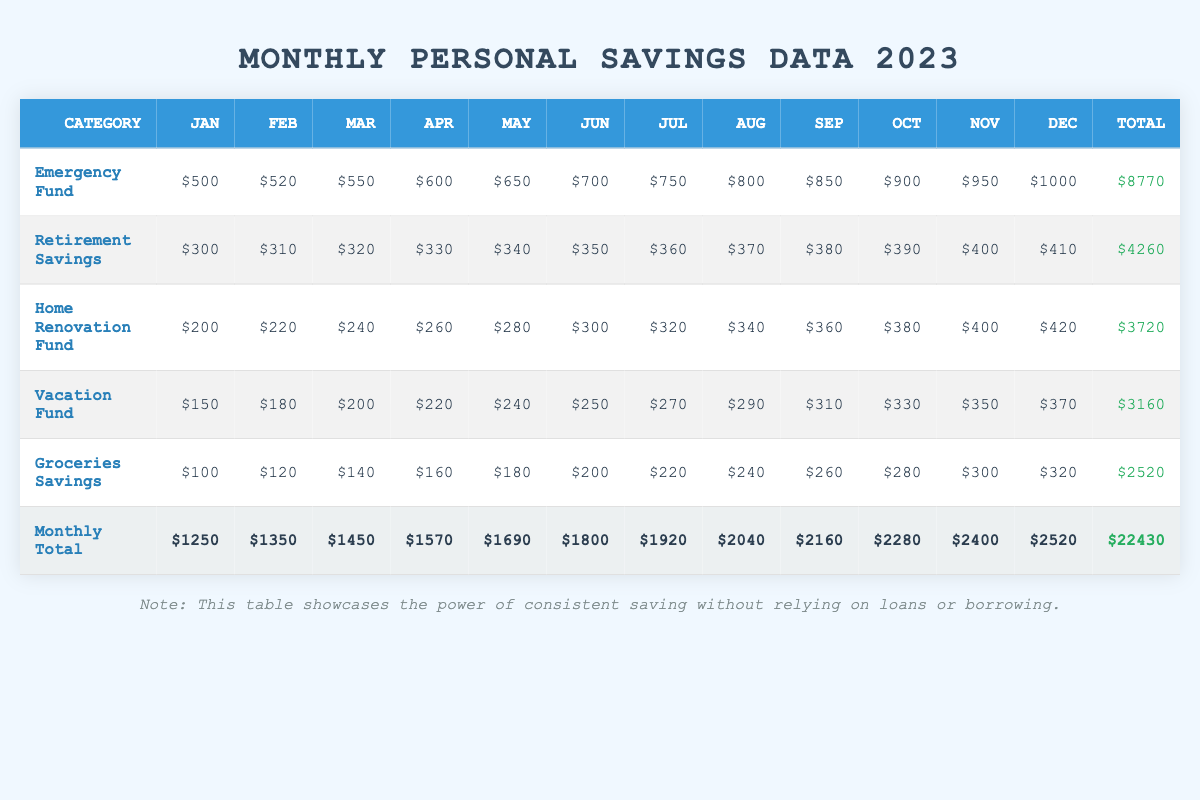What is the total savings in the Emergency Fund by December? The table shows that the Emergency Fund savings amount for December is $1000.
Answer: $1000 Which category saw the highest contribution in January? From the January data, the Emergency Fund has the highest contribution at $500, compared to other categories.
Answer: Emergency Fund What is the total savings contributed to the Vacation Fund for the entire year? To find the total for the Vacation Fund, add each month's contributions: $150 + $180 + $200 + $220 + $240 + $250 + $270 + $290 + $310 + $330 + $350 + $370 = $3160.
Answer: $3160 Did the Groceries Savings increase every month? Reviewing the month-to-month contributions for Groceries Savings shows a consistent increase: $100, $120, $140, $160, $180, $200, $220, $240, $260, $280, $300, $320, indicating a monthly increase.
Answer: Yes What is the average monthly saving for the Retirement Savings category? The total for Retirement Savings is $4260, calculated for 12 months, resulting in an average of $4260 / 12 = $355.
Answer: $355 Which month had the highest total savings across all categories? Analyzing the Monthly Total row, December had the highest total savings at $2520 compared to other months.
Answer: December How much more was saved in the Home Renovation Fund in November compared to January? The Home Renovation Fund saved $400 in November and $200 in January. The difference is $400 - $200 = $200.
Answer: $200 Which categories had savings of more than $300 in October? Reviewing October's columns, the Emergency Fund ($900), Retirement Savings ($390), and Home Renovation Fund ($380) all exceeded $300.
Answer: Emergency Fund, Retirement Savings, Home Renovation Fund What was the total savings for all categories in July? To calculate the total for July, sum the individual category savings: $750 + $360 + $320 + $270 + $220 = $1920.
Answer: $1920 What percentage of total savings did the Groceries Savings contribute over the year? The total savings for Groceries is $2520. The overall total savings for the year is $22430. The percentage is calculated as ($2520 / $22430) * 100 ≈ 11.23%.
Answer: Approximately 11.23% 